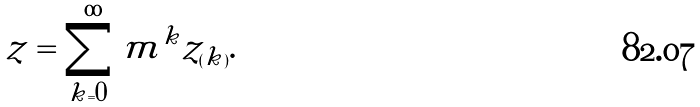Convert formula to latex. <formula><loc_0><loc_0><loc_500><loc_500>z = \sum _ { k = 0 } ^ { \infty } m ^ { k } z _ { ( k ) } .</formula> 